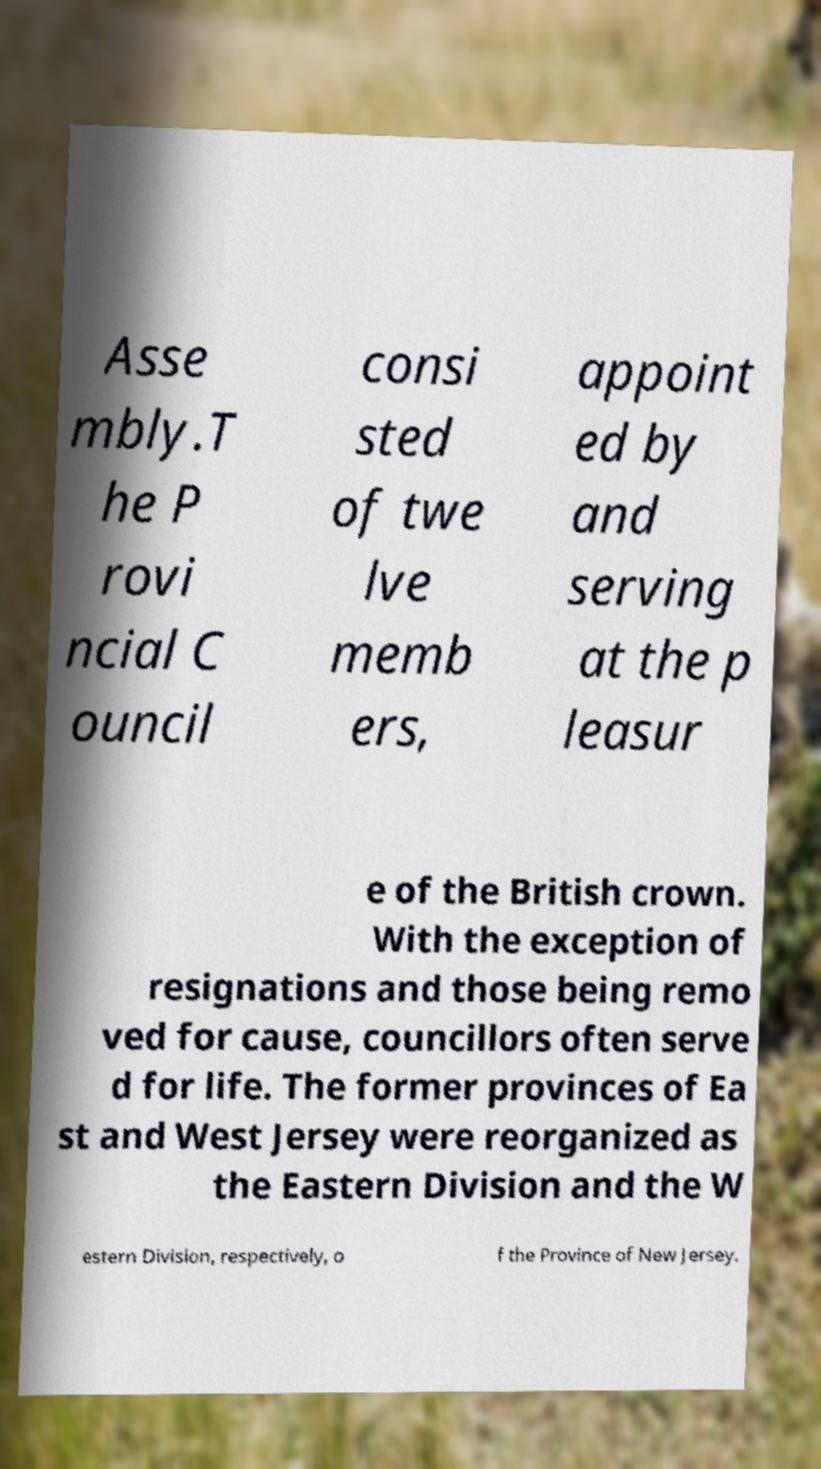Please read and relay the text visible in this image. What does it say? Asse mbly.T he P rovi ncial C ouncil consi sted of twe lve memb ers, appoint ed by and serving at the p leasur e of the British crown. With the exception of resignations and those being remo ved for cause, councillors often serve d for life. The former provinces of Ea st and West Jersey were reorganized as the Eastern Division and the W estern Division, respectively, o f the Province of New Jersey. 